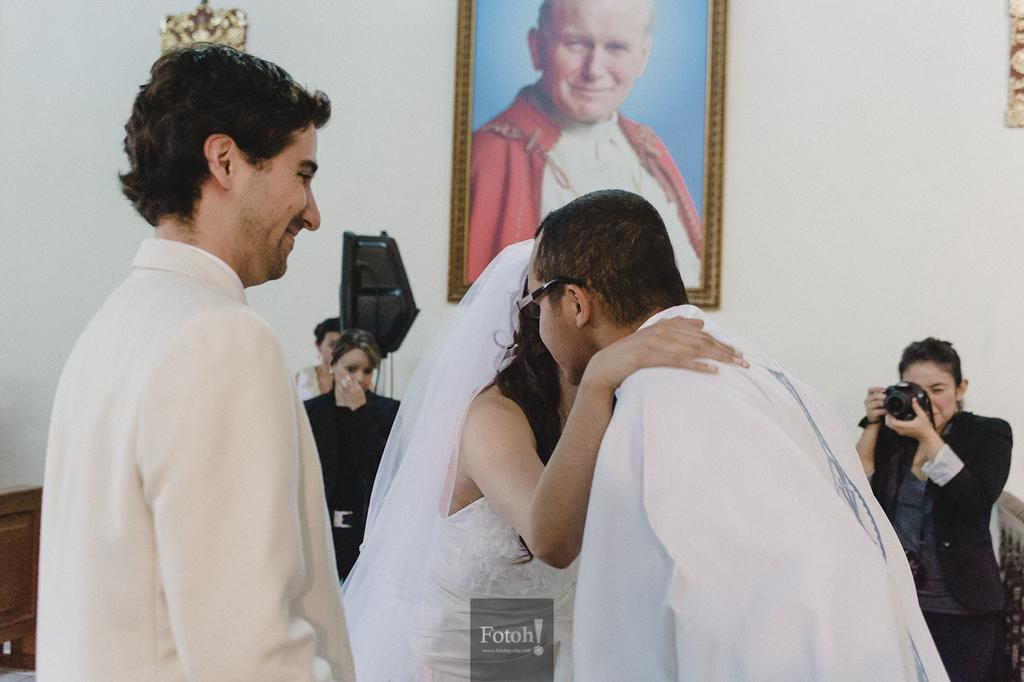What can be observed about the people in the image? There are people standing in the image. Can you describe the woman on the right side of the image? The woman on the right side of the image is standing and holding a camera. What is present on the wall in the image? There is a wall in the image, and there is a photo on the wall. What type of yam is being roasted in the fire in the image? There is no yam or fire present in the image. How does the root contribute to the scene in the image? There is no root mentioned in the image, so it cannot contribute to the scene. 